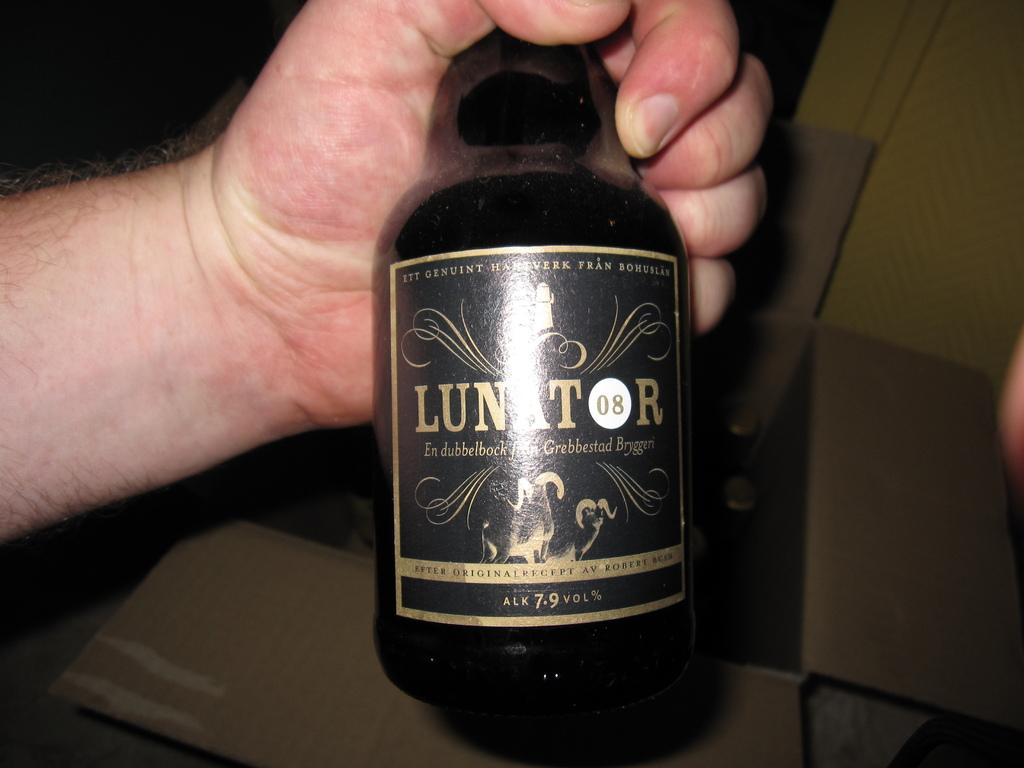<image>
Summarize the visual content of the image. Someone holding a bottle of Luntor 08 in their hand. 